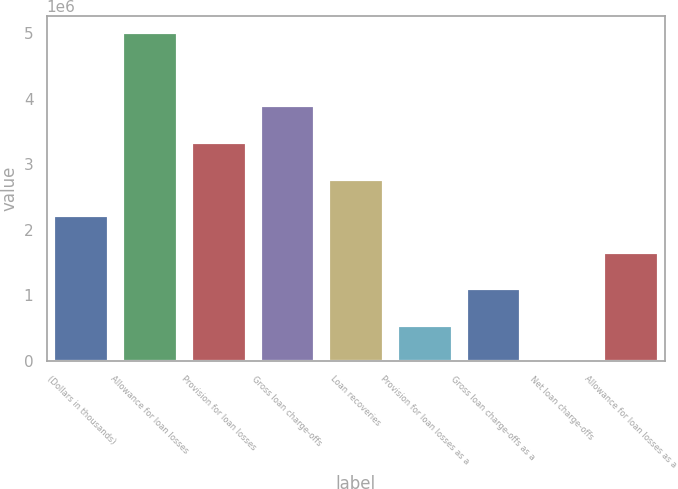Convert chart to OTSL. <chart><loc_0><loc_0><loc_500><loc_500><bar_chart><fcel>(Dollars in thousands)<fcel>Allowance for loan losses<fcel>Provision for loan losses<fcel>Gross loan charge-offs<fcel>Loan recoveries<fcel>Provision for loan losses as a<fcel>Gross loan charge-offs as a<fcel>Net loan charge-offs<fcel>Allowance for loan losses as a<nl><fcel>2.22688e+06<fcel>5.01048e+06<fcel>3.34032e+06<fcel>3.89704e+06<fcel>2.7836e+06<fcel>556721<fcel>1.11344e+06<fcel>0.77<fcel>1.67016e+06<nl></chart> 